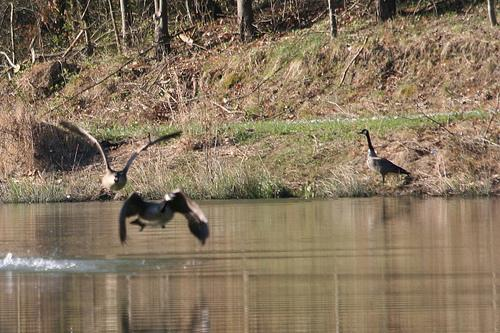These animals have an impressive what? Please explain your reasoning. wingspan. The span of the wings on these birds is impressive. 